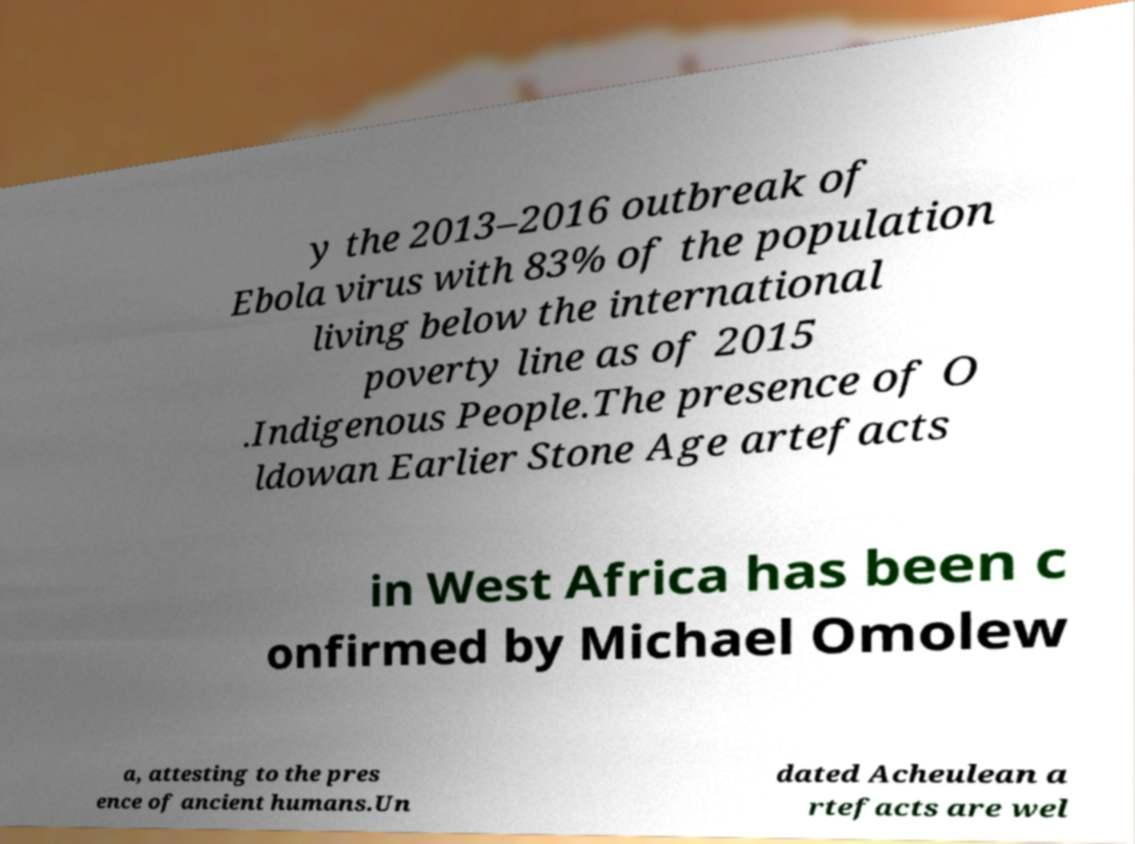There's text embedded in this image that I need extracted. Can you transcribe it verbatim? y the 2013–2016 outbreak of Ebola virus with 83% of the population living below the international poverty line as of 2015 .Indigenous People.The presence of O ldowan Earlier Stone Age artefacts in West Africa has been c onfirmed by Michael Omolew a, attesting to the pres ence of ancient humans.Un dated Acheulean a rtefacts are wel 